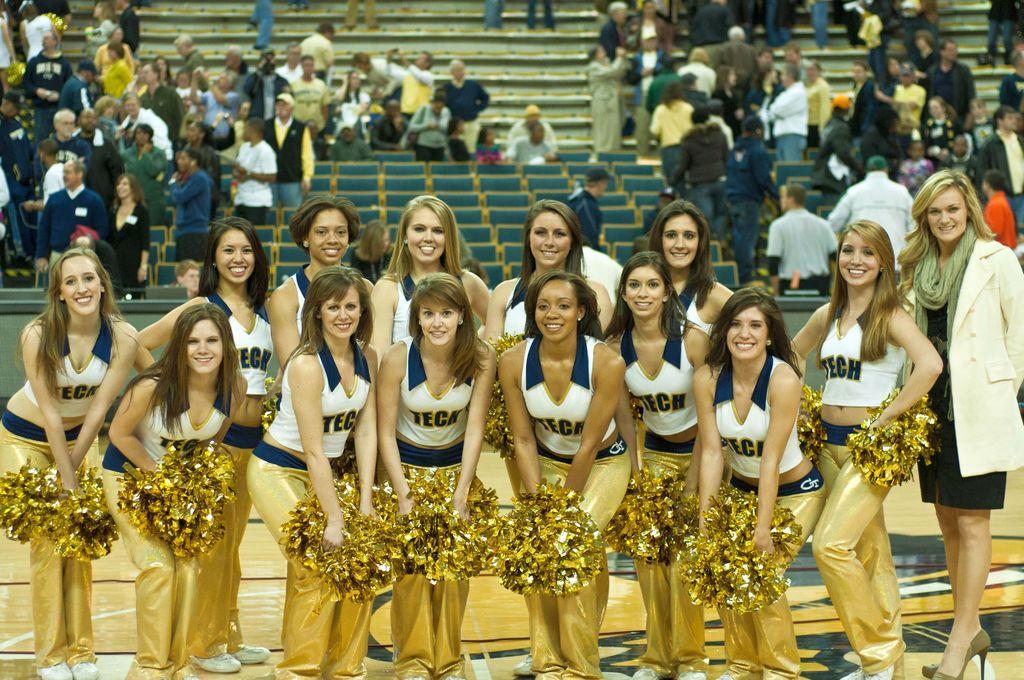What team do these cheerleaders cheer for?
Your answer should be very brief. Tech. What is the 2 capitalized letters on the band of the pants?
Provide a succinct answer. Ct. 